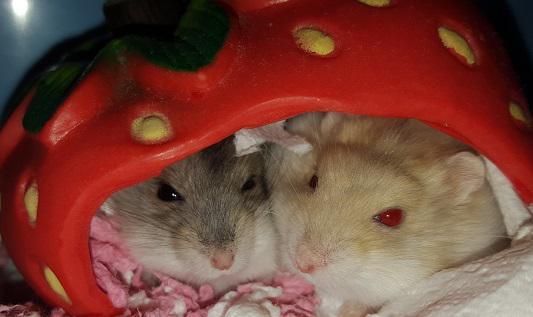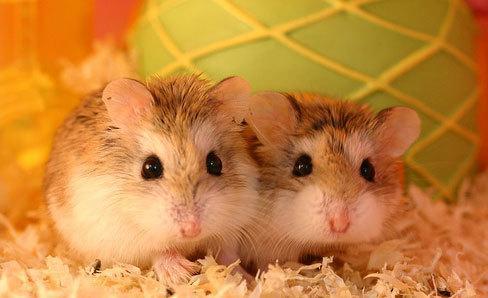The first image is the image on the left, the second image is the image on the right. Given the left and right images, does the statement "Every hamster is inside a wheel, and every hamster wheel is bright blue." hold true? Answer yes or no. No. The first image is the image on the left, the second image is the image on the right. Analyze the images presented: Is the assertion "Each image shows exactly two rodents." valid? Answer yes or no. Yes. 